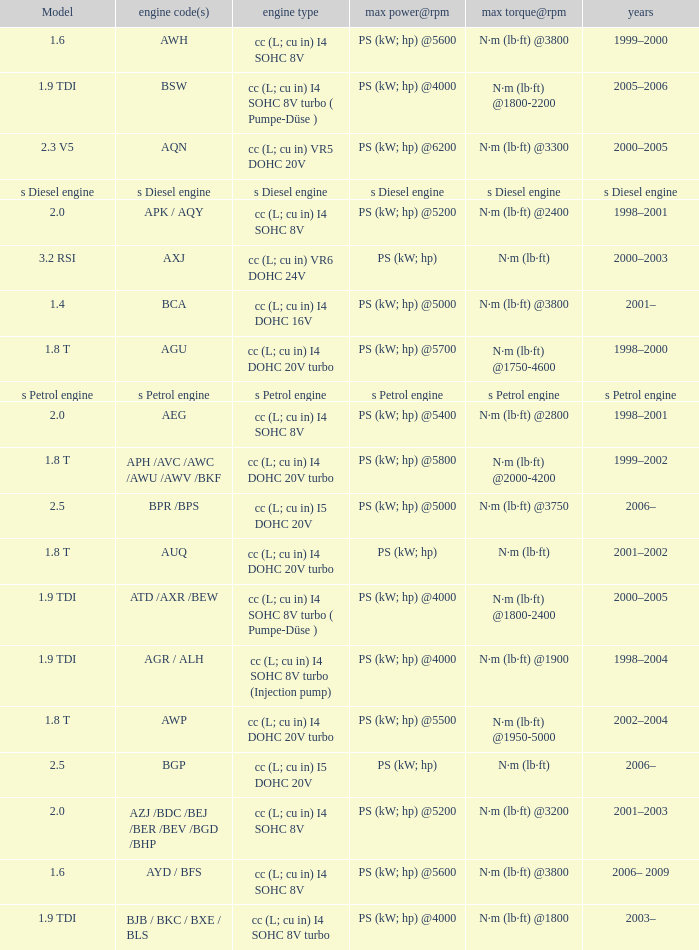What was the max torque@rpm of the engine which had the model 2.5  and a max power@rpm of ps (kw; hp) @5000? N·m (lb·ft) @3750. 